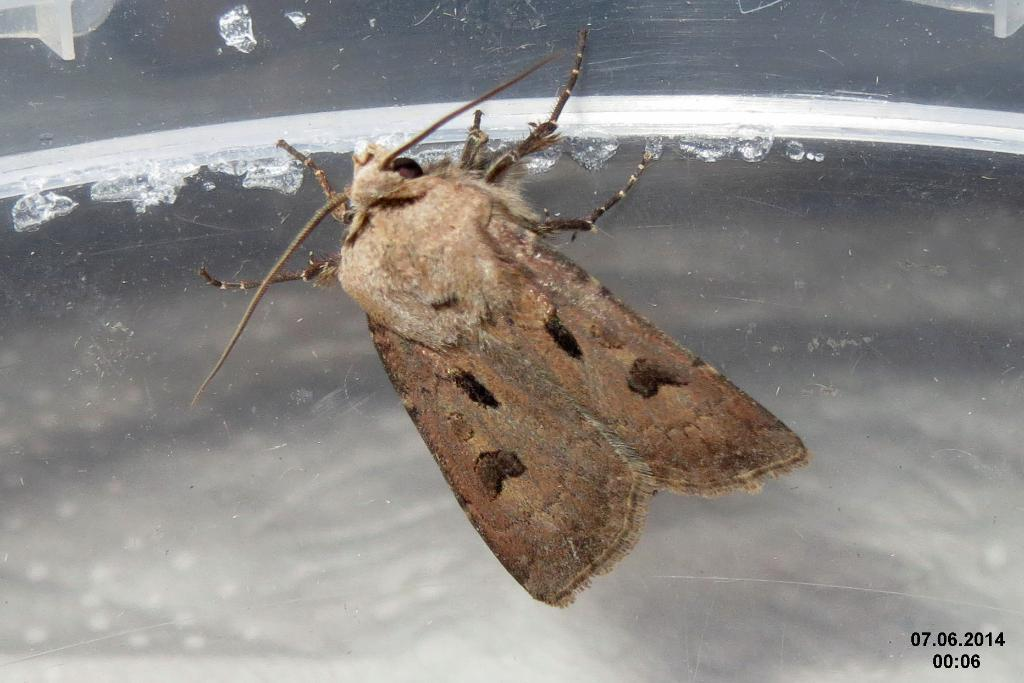What type of creature is in the image? There is an insect in the image. What is the insect resting on in the image? The insect is on a transparent object. Where is the insect located in relation to the image? The insect is in the foreground of the image. What is the insect's primary mode of transport in the image? The insect does not have a mode of transport in the image; it is stationary on the transparent object. 